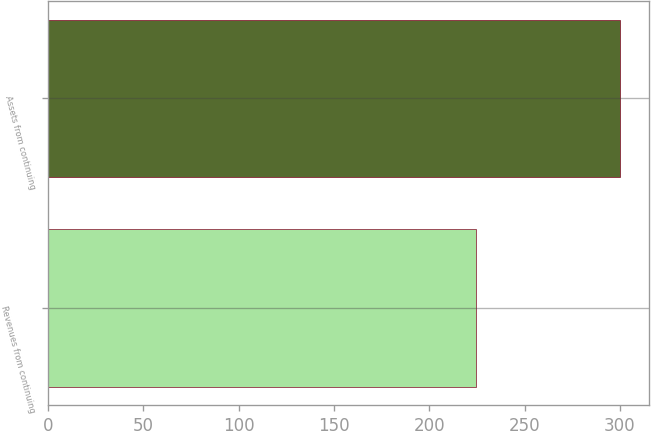Convert chart to OTSL. <chart><loc_0><loc_0><loc_500><loc_500><bar_chart><fcel>Revenues from continuing<fcel>Assets from continuing<nl><fcel>224.4<fcel>300.3<nl></chart> 